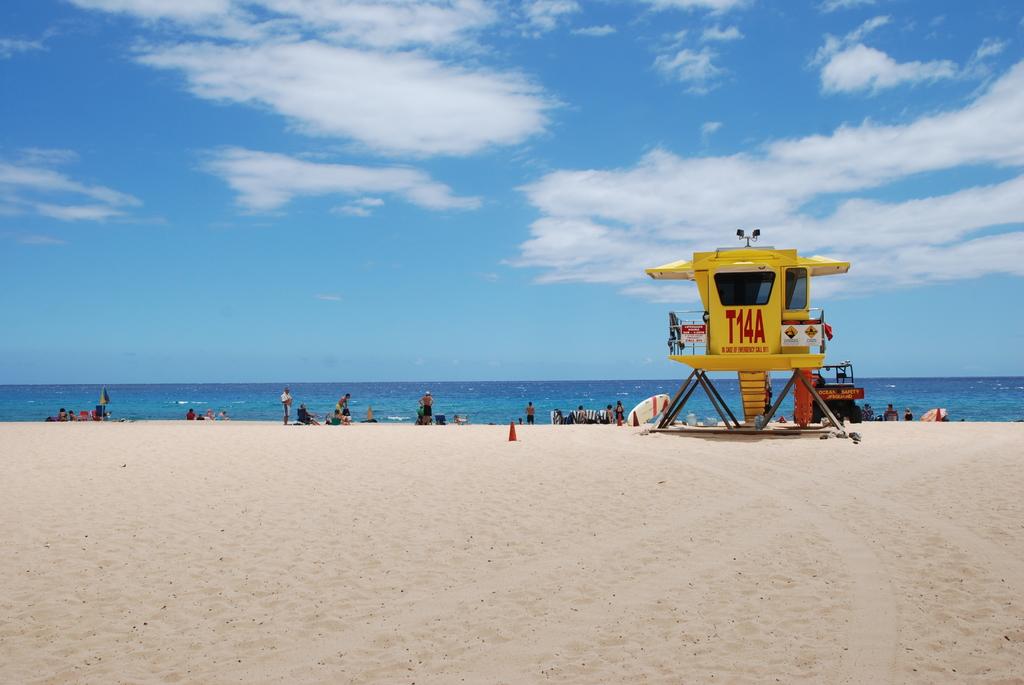What is the lifeguard station named?
Give a very brief answer. T14a. What number lifeguard station is this?
Make the answer very short. T14a. 